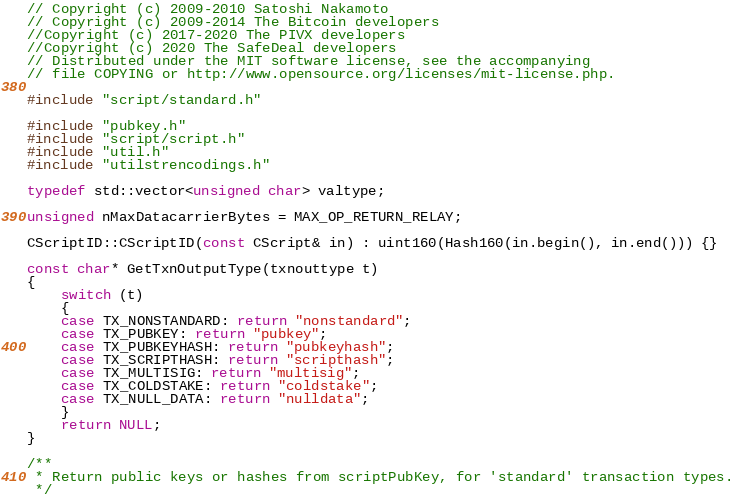<code> <loc_0><loc_0><loc_500><loc_500><_C++_>// Copyright (c) 2009-2010 Satoshi Nakamoto
// Copyright (c) 2009-2014 The Bitcoin developers
//Copyright (c) 2017-2020 The PIVX developers
//Copyright (c) 2020 The SafeDeal developers
// Distributed under the MIT software license, see the accompanying
// file COPYING or http://www.opensource.org/licenses/mit-license.php.

#include "script/standard.h"

#include "pubkey.h"
#include "script/script.h"
#include "util.h"
#include "utilstrencodings.h"

typedef std::vector<unsigned char> valtype;

unsigned nMaxDatacarrierBytes = MAX_OP_RETURN_RELAY;

CScriptID::CScriptID(const CScript& in) : uint160(Hash160(in.begin(), in.end())) {}

const char* GetTxnOutputType(txnouttype t)
{
    switch (t)
    {
    case TX_NONSTANDARD: return "nonstandard";
    case TX_PUBKEY: return "pubkey";
    case TX_PUBKEYHASH: return "pubkeyhash";
    case TX_SCRIPTHASH: return "scripthash";
    case TX_MULTISIG: return "multisig";
    case TX_COLDSTAKE: return "coldstake";
    case TX_NULL_DATA: return "nulldata";
    }
    return NULL;
}

/**
 * Return public keys or hashes from scriptPubKey, for 'standard' transaction types.
 */</code> 